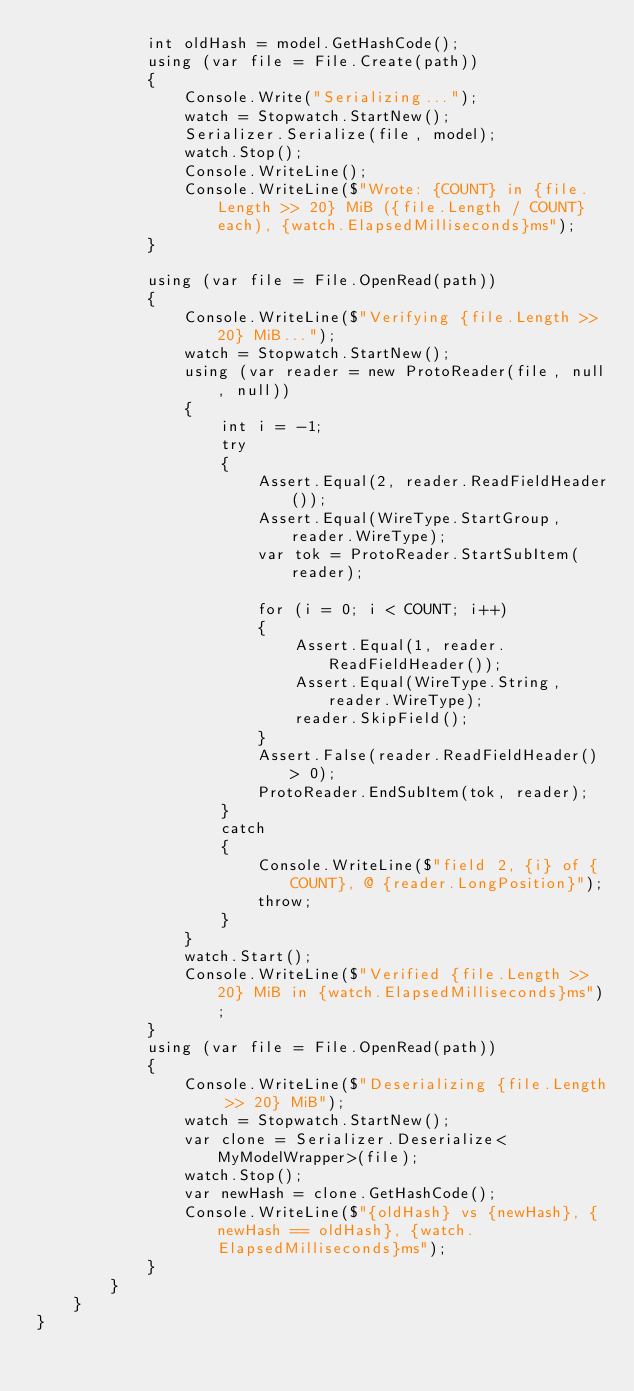Convert code to text. <code><loc_0><loc_0><loc_500><loc_500><_C#_>            int oldHash = model.GetHashCode();
            using (var file = File.Create(path))
            {
                Console.Write("Serializing...");
                watch = Stopwatch.StartNew();
                Serializer.Serialize(file, model);
                watch.Stop();
                Console.WriteLine();
                Console.WriteLine($"Wrote: {COUNT} in {file.Length >> 20} MiB ({file.Length / COUNT} each), {watch.ElapsedMilliseconds}ms");
            }

            using (var file = File.OpenRead(path))
            {
                Console.WriteLine($"Verifying {file.Length >> 20} MiB...");
                watch = Stopwatch.StartNew();
                using (var reader = new ProtoReader(file, null, null))
                {
                    int i = -1;
                    try
                    {
                        Assert.Equal(2, reader.ReadFieldHeader());
                        Assert.Equal(WireType.StartGroup, reader.WireType);
                        var tok = ProtoReader.StartSubItem(reader);

                        for (i = 0; i < COUNT; i++)
                        {
                            Assert.Equal(1, reader.ReadFieldHeader());
                            Assert.Equal(WireType.String, reader.WireType);
                            reader.SkipField();
                        }
                        Assert.False(reader.ReadFieldHeader() > 0);
                        ProtoReader.EndSubItem(tok, reader);
                    }
                    catch
                    {
                        Console.WriteLine($"field 2, {i} of {COUNT}, @ {reader.LongPosition}");
                        throw;
                    }
                }
                watch.Start();
                Console.WriteLine($"Verified {file.Length >> 20} MiB in {watch.ElapsedMilliseconds}ms");
            }
            using (var file = File.OpenRead(path))
            {
                Console.WriteLine($"Deserializing {file.Length >> 20} MiB");
                watch = Stopwatch.StartNew();
                var clone = Serializer.Deserialize<MyModelWrapper>(file);
                watch.Stop();
                var newHash = clone.GetHashCode();
                Console.WriteLine($"{oldHash} vs {newHash}, {newHash == oldHash}, {watch.ElapsedMilliseconds}ms");
            }
        }
    }
}
</code> 